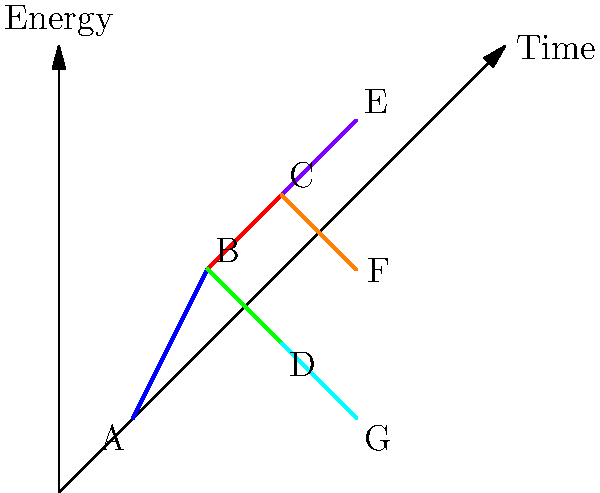In the given event display of a particle decay chain, what type of decay process is most likely represented by the transition from particle B to particles C and D? To answer this question, let's analyze the event display step-by-step:

1. The diagram shows a particle decay chain over time, with energy on the vertical axis.

2. We observe the following sequence:
   - Particle A decays into particle B (blue line)
   - Particle B then decays into two particles: C and D (red and green lines)
   - Particles C and D subsequently decay further

3. The key feature to focus on is the decay of particle B into C and D. This bifurcation represents a particle splitting into two daughter particles.

4. In particle physics, when a particle decays into two particles, it's typically a sign of one of these processes:
   a) Strong decay
   b) Electromagnetic decay
   c) Weak decay

5. Given that this is a theoretical physics question relying on collider experiment data, we need to consider the most common and significant decay processes observed in such experiments.

6. The strong and electromagnetic decays are generally much faster than weak decays, occurring almost instantaneously after the particle's creation.

7. In high-energy physics experiments, such as those conducted at particle colliders, many of the observed decay chains involve strong decays due to their high probability and quick occurrence.

8. The branching of the decay chain at particle B, producing two new particles with significant energy (as indicated by their upward trajectories), is characteristic of a strong decay process.

Therefore, based on the event display and the context of collider experiments, the most likely type of decay process represented by the transition from particle B to particles C and D is a strong decay.
Answer: Strong decay 